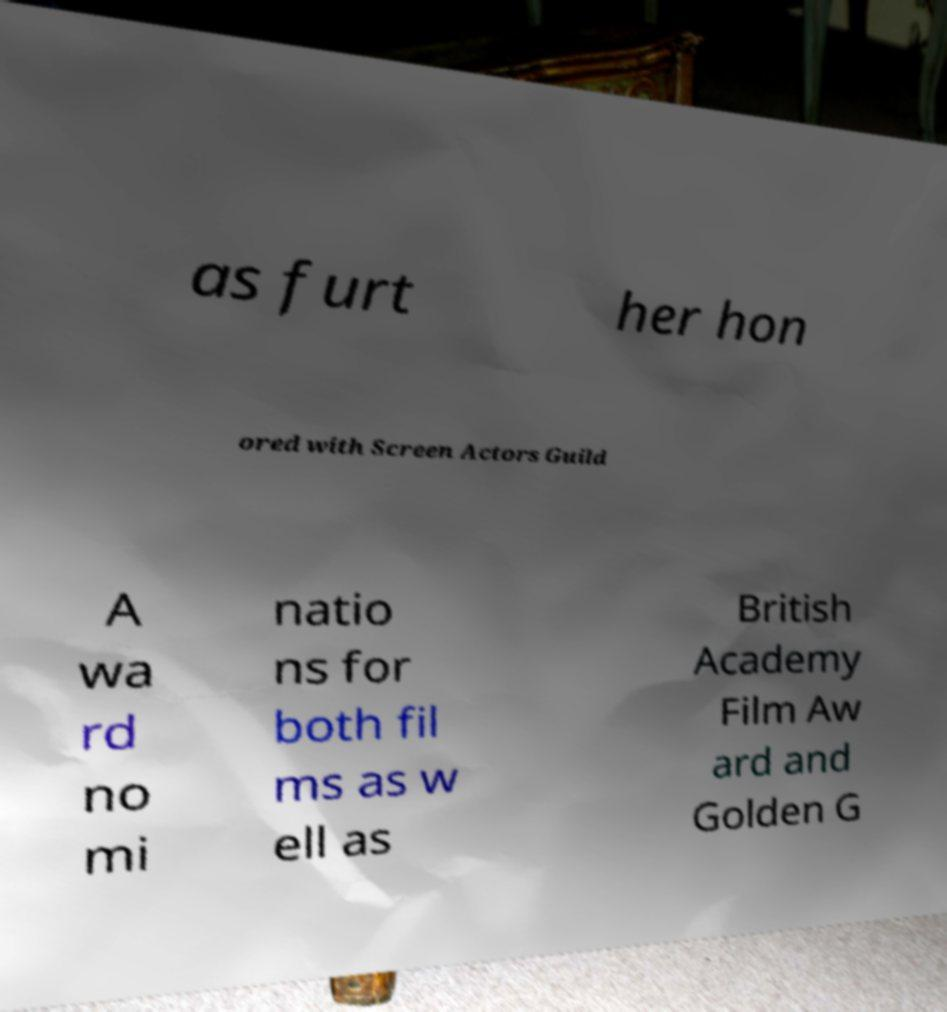I need the written content from this picture converted into text. Can you do that? as furt her hon ored with Screen Actors Guild A wa rd no mi natio ns for both fil ms as w ell as British Academy Film Aw ard and Golden G 